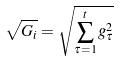Convert formula to latex. <formula><loc_0><loc_0><loc_500><loc_500>\sqrt { G _ { i } } = \sqrt { \sum _ { \tau = 1 } ^ { t } g _ { \tau } ^ { 2 } }</formula> 